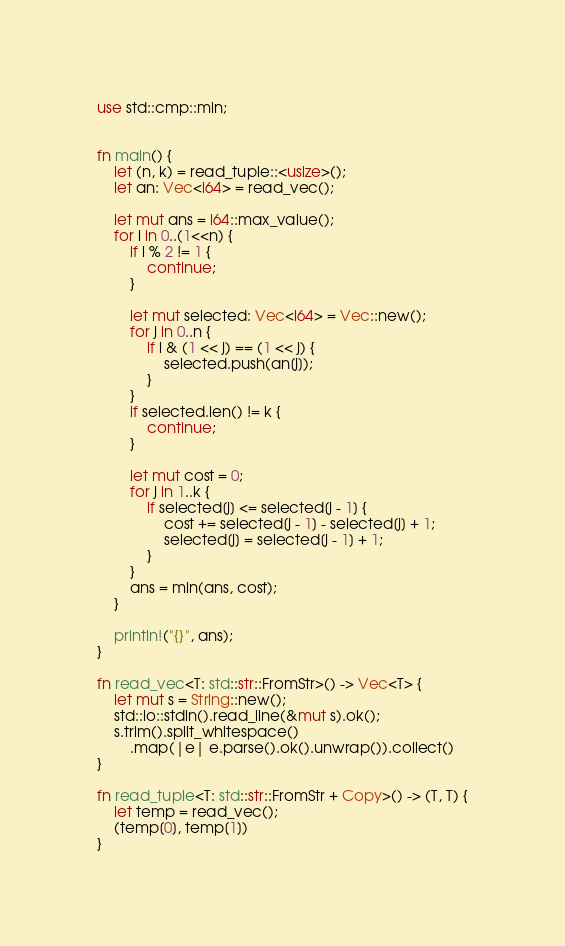Convert code to text. <code><loc_0><loc_0><loc_500><loc_500><_Rust_>use std::cmp::min;


fn main() {
    let (n, k) = read_tuple::<usize>();
    let an: Vec<i64> = read_vec();

    let mut ans = i64::max_value();
    for i in 0..(1<<n) {
        if i % 2 != 1 {
            continue;
        }

        let mut selected: Vec<i64> = Vec::new();
        for j in 0..n {
            if i & (1 << j) == (1 << j) {
                selected.push(an[j]);
            }
        }
        if selected.len() != k {
            continue;
        }

        let mut cost = 0;
        for j in 1..k {
            if selected[j] <= selected[j - 1] {
                cost += selected[j - 1] - selected[j] + 1;
                selected[j] = selected[j - 1] + 1;
            }
        }
        ans = min(ans, cost);
    }

    println!("{}", ans);
}

fn read_vec<T: std::str::FromStr>() -> Vec<T> {
    let mut s = String::new();
    std::io::stdin().read_line(&mut s).ok();
    s.trim().split_whitespace()
        .map(|e| e.parse().ok().unwrap()).collect()
}

fn read_tuple<T: std::str::FromStr + Copy>() -> (T, T) {
    let temp = read_vec();
    (temp[0], temp[1])
}
</code> 